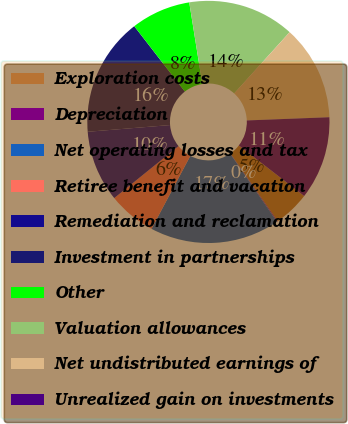Convert chart to OTSL. <chart><loc_0><loc_0><loc_500><loc_500><pie_chart><fcel>Exploration costs<fcel>Depreciation<fcel>Net operating losses and tax<fcel>Retiree benefit and vacation<fcel>Remediation and reclamation<fcel>Investment in partnerships<fcel>Other<fcel>Valuation allowances<fcel>Net undistributed earnings of<fcel>Unrealized gain on investments<nl><fcel>4.82%<fcel>0.11%<fcel>17.38%<fcel>6.39%<fcel>9.53%<fcel>15.81%<fcel>7.96%<fcel>14.24%<fcel>12.67%<fcel>11.1%<nl></chart> 